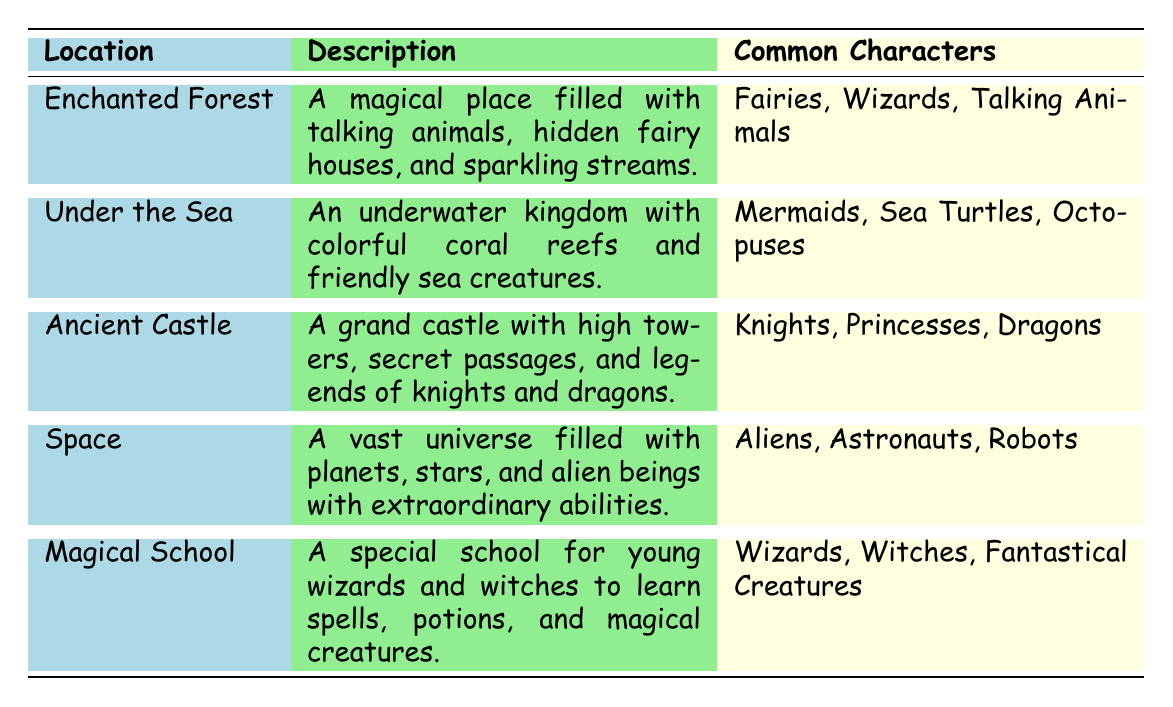What is the description of the Enchanted Forest? The description of the Enchanted Forest is found in the second column of the table. It states, "A magical place filled with talking animals, hidden fairy houses, and sparkling streams."
Answer: A magical place filled with talking animals, hidden fairy houses, and sparkling streams Which location features mermaids as common characters? By looking at the common characters listed in the third column, we see that "Mermaids" are associated with the location "Under the Sea."
Answer: Under the Sea What are the themes associated with the Ancient Castle? To find the themes for the Ancient Castle, we would look for it in the table and see that it lists "Bravery," "Chivalry," and "Loyalty" under themes.
Answer: Bravery, Chivalry, Loyalty How many stories are listed for the Magical School? We can count the number of stories in the fourth column for the Magical School where the stories are "The Wizard's Apprentice," "The Potion Mishap," and "The Great Magical Show," resulting in a count of 3.
Answer: 3 Which location has the theme of "Environmental Awareness"? Checking the themes in the table, we see "Environmental Awareness" is listed under the location "Under the Sea."
Answer: Under the Sea Is there a story associated with the Mountain Peak? By reviewing the table, the Mountain Peak has stories listed: "The Climb to the Summit," "The Eagle's Gift," and "Mountain Legends," which confirms there are stories linked to it.
Answer: Yes How many different common characters are mentioned for locations related to magic (Enchanted Forest, Magical School)? First, we identify the common characters for each magical location: Enchanted Forest has 3 characters (Fairies, Wizards, Talking Animals) and Magical School has 3 characters (Wizards, Witches, Fantastical Creatures). Then we total them: 3 + 3 = 6.
Answer: 6 List the stories linked to the location of Wonderland. Referring to the table under the stories section for Wonderland, we find the stories: "Alice in Wonderland," "Through the Looking Glass," and "The Mad Tea Party."
Answer: Alice in Wonderland, Through the Looking Glass, The Mad Tea Party Which character is common in both the Magical School and Enchanted Forest? We check the common characters for both locations; "Wizards" appear in the Magical School and "Fairies" and "Talking Animals" are in the Enchanted Forest. Comparing them reveals that “Wizards” is the only character that fits.
Answer: No common characters Which setting has the most themes listed, and how many themes does it have? We can see that each location has themes listed. The Enchanted Forest has 3 (Magic, Adventure, Friendship), Under the Sea has 3 (Exploration, Courage, Environmental Awareness), and so on. Counting shows that all have 3 themes, thus no specific location stands out.
Answer: All locations have 3 themes 